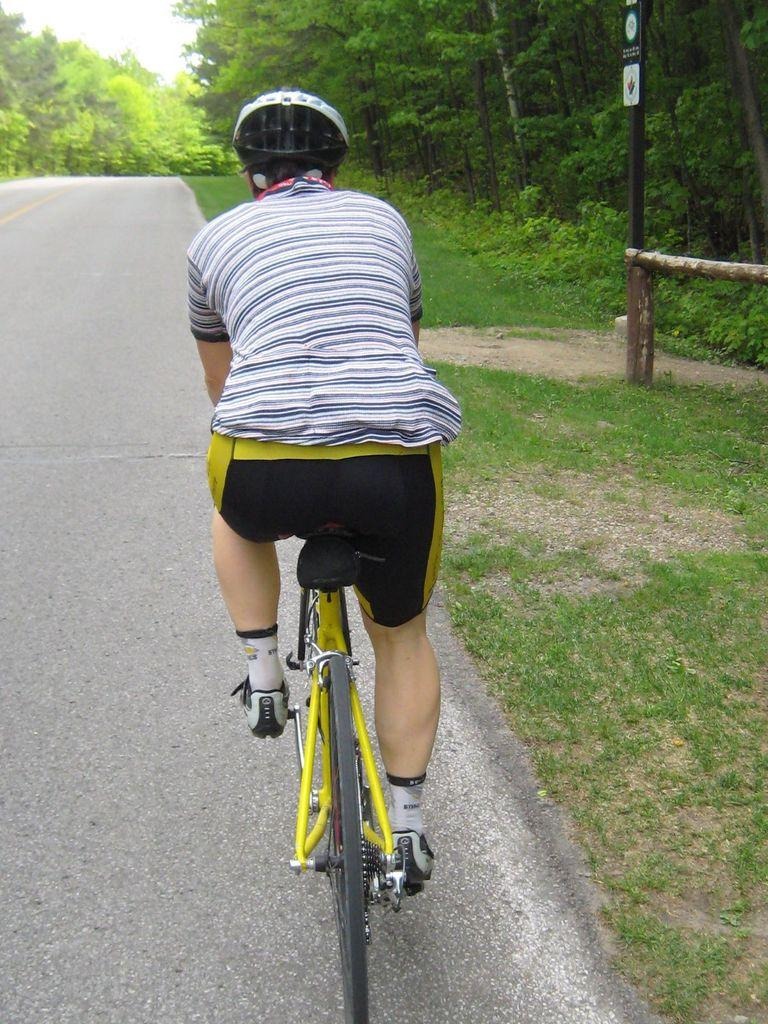What is the main subject of the image? There is a person in the image. What is the person wearing on their head? The person is wearing a white helmet. What is the person riding in the image? The person is riding a yellow bicycle. Where is the bicycle located? The bicycle is on a road. What can be seen on either side of the road? There are trees on either side of the road. How many divisions of ants can be seen on the road in the image? There are no ants present in the image, so it is not possible to determine the number of divisions. 